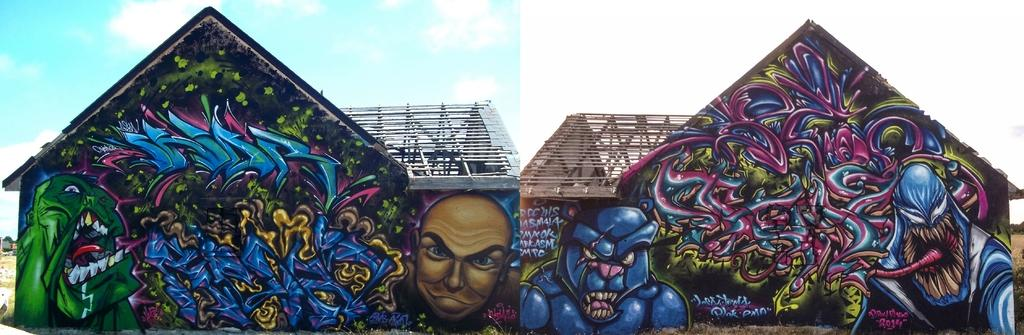What type of structures are visible in the image? There are houses and buildings in the image. What natural elements can be seen in the image? There are trees and grass in the image. What is visible in the background of the image? The sky is visible in the image. What type of surface is present in the image? There are visible in the image. How can you tell that the image might be edited? The image appears to be an edited photo. What type of lead can be seen in the image? There is no lead present in the image. Can you tell me what story is being told in the image? The image does not depict a story; it is a scene with houses, buildings, trees, grass, and the sky. 